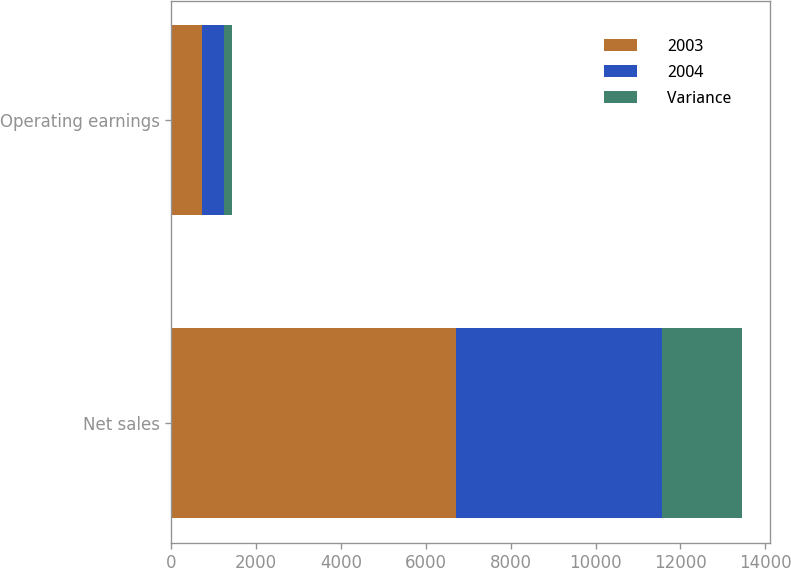Convert chart. <chart><loc_0><loc_0><loc_500><loc_500><stacked_bar_chart><ecel><fcel>Net sales<fcel>Operating earnings<nl><fcel>2003<fcel>6722<fcel>718<nl><fcel>2004<fcel>4848<fcel>533<nl><fcel>Variance<fcel>1874<fcel>185<nl></chart> 